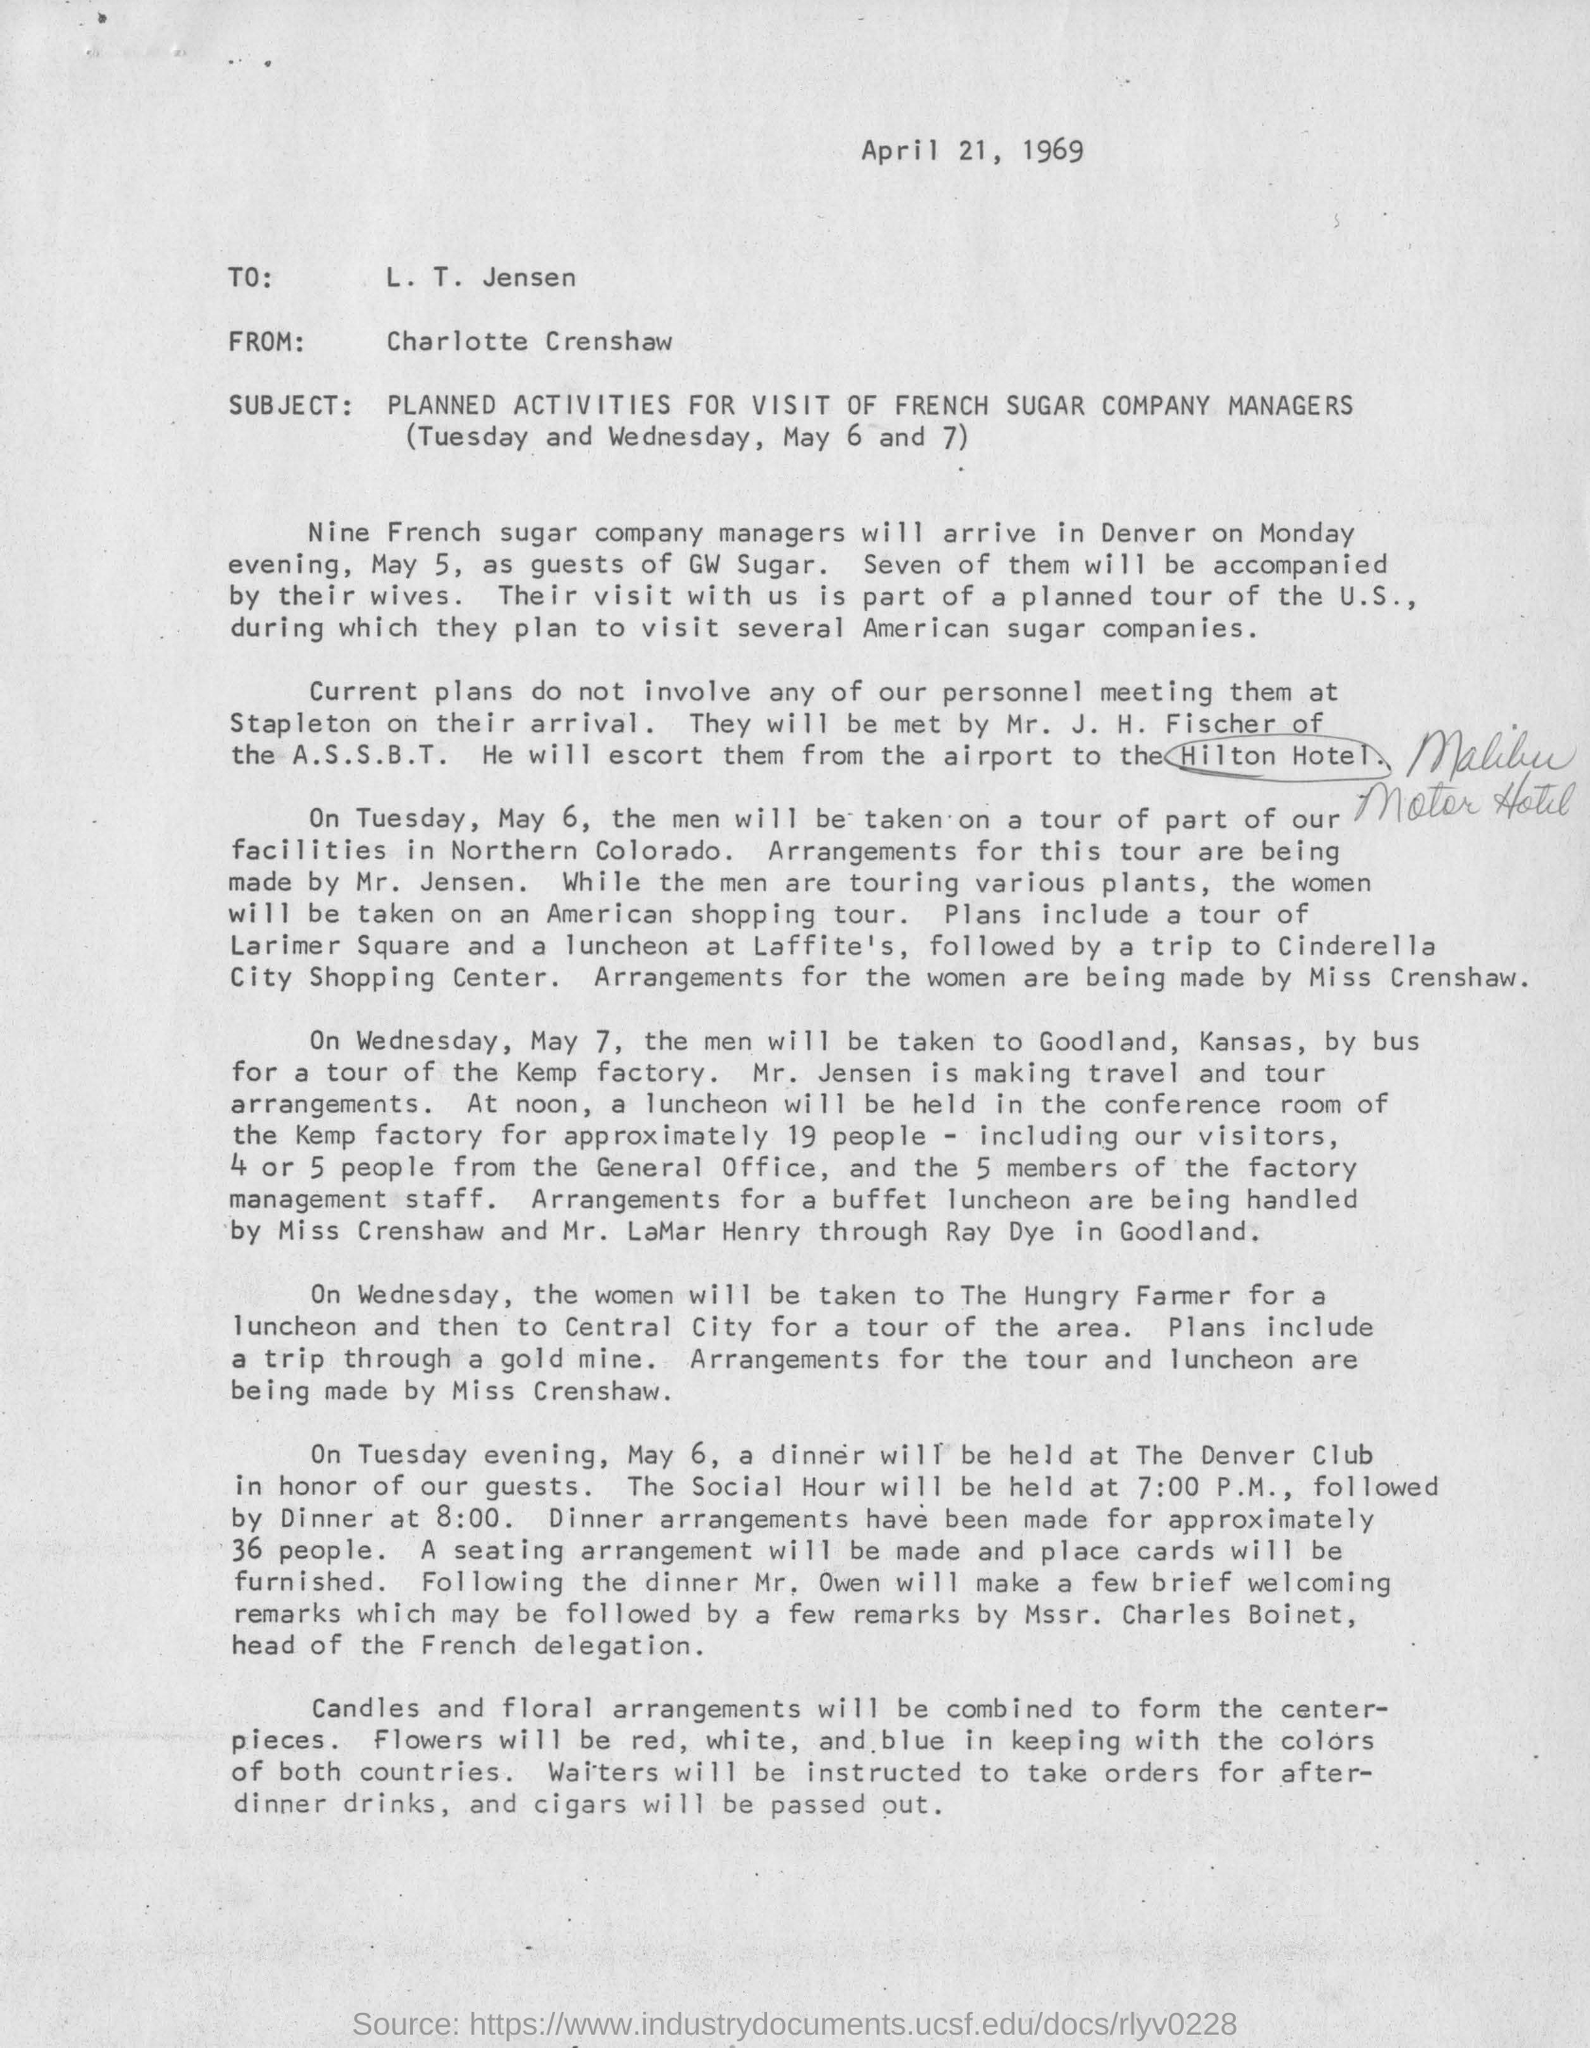What is the subject of this letter
Offer a terse response. PLANNED ACTIVITIES FOR VISIT OF FRENCH SUGAR COMPANY MANAGERS. When will nine french sugar company managers arrive in denver?
Keep it short and to the point. On monday evening, may 5. How many of them will be accompanied by their wives
Ensure brevity in your answer.  SEVEN. Who is made responsible for this tour arrangements?
Provide a succinct answer. Mr. Jensen. What will be combined to form the center-pieces
Your response must be concise. Candles and floral arrangements. What will be passed out
Your response must be concise. Cigars. 